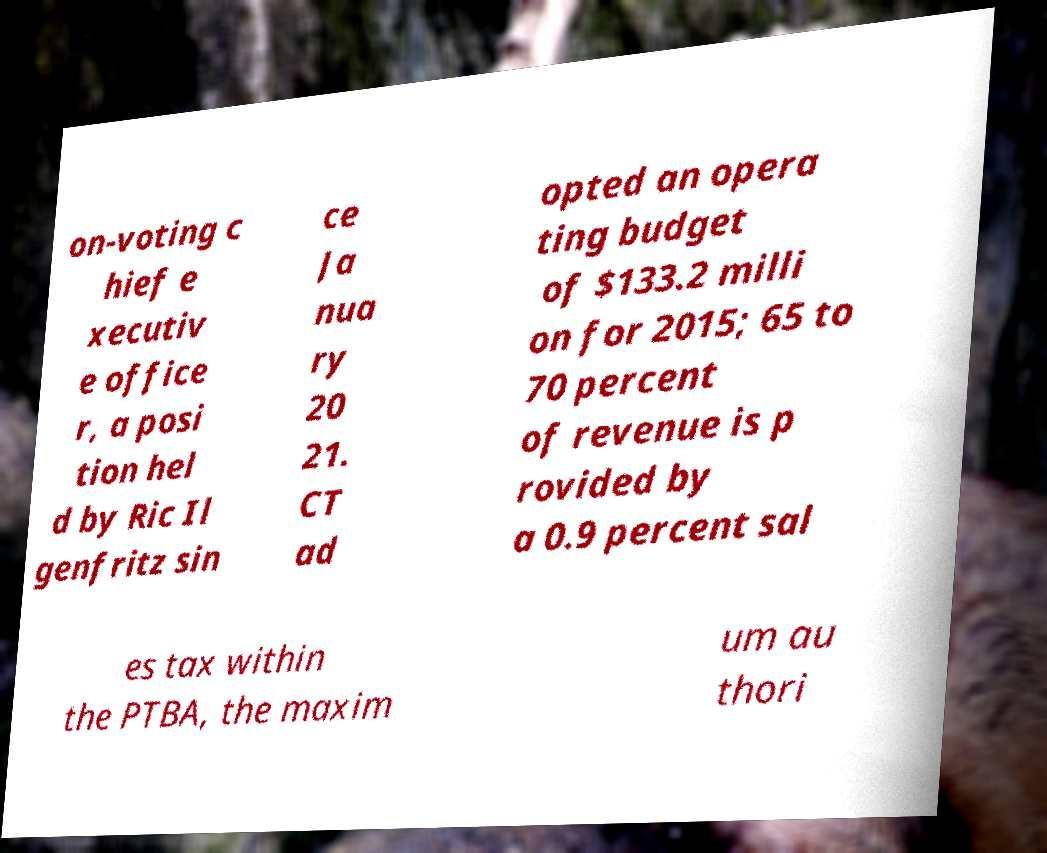Could you extract and type out the text from this image? on-voting c hief e xecutiv e office r, a posi tion hel d by Ric Il genfritz sin ce Ja nua ry 20 21. CT ad opted an opera ting budget of $133.2 milli on for 2015; 65 to 70 percent of revenue is p rovided by a 0.9 percent sal es tax within the PTBA, the maxim um au thori 